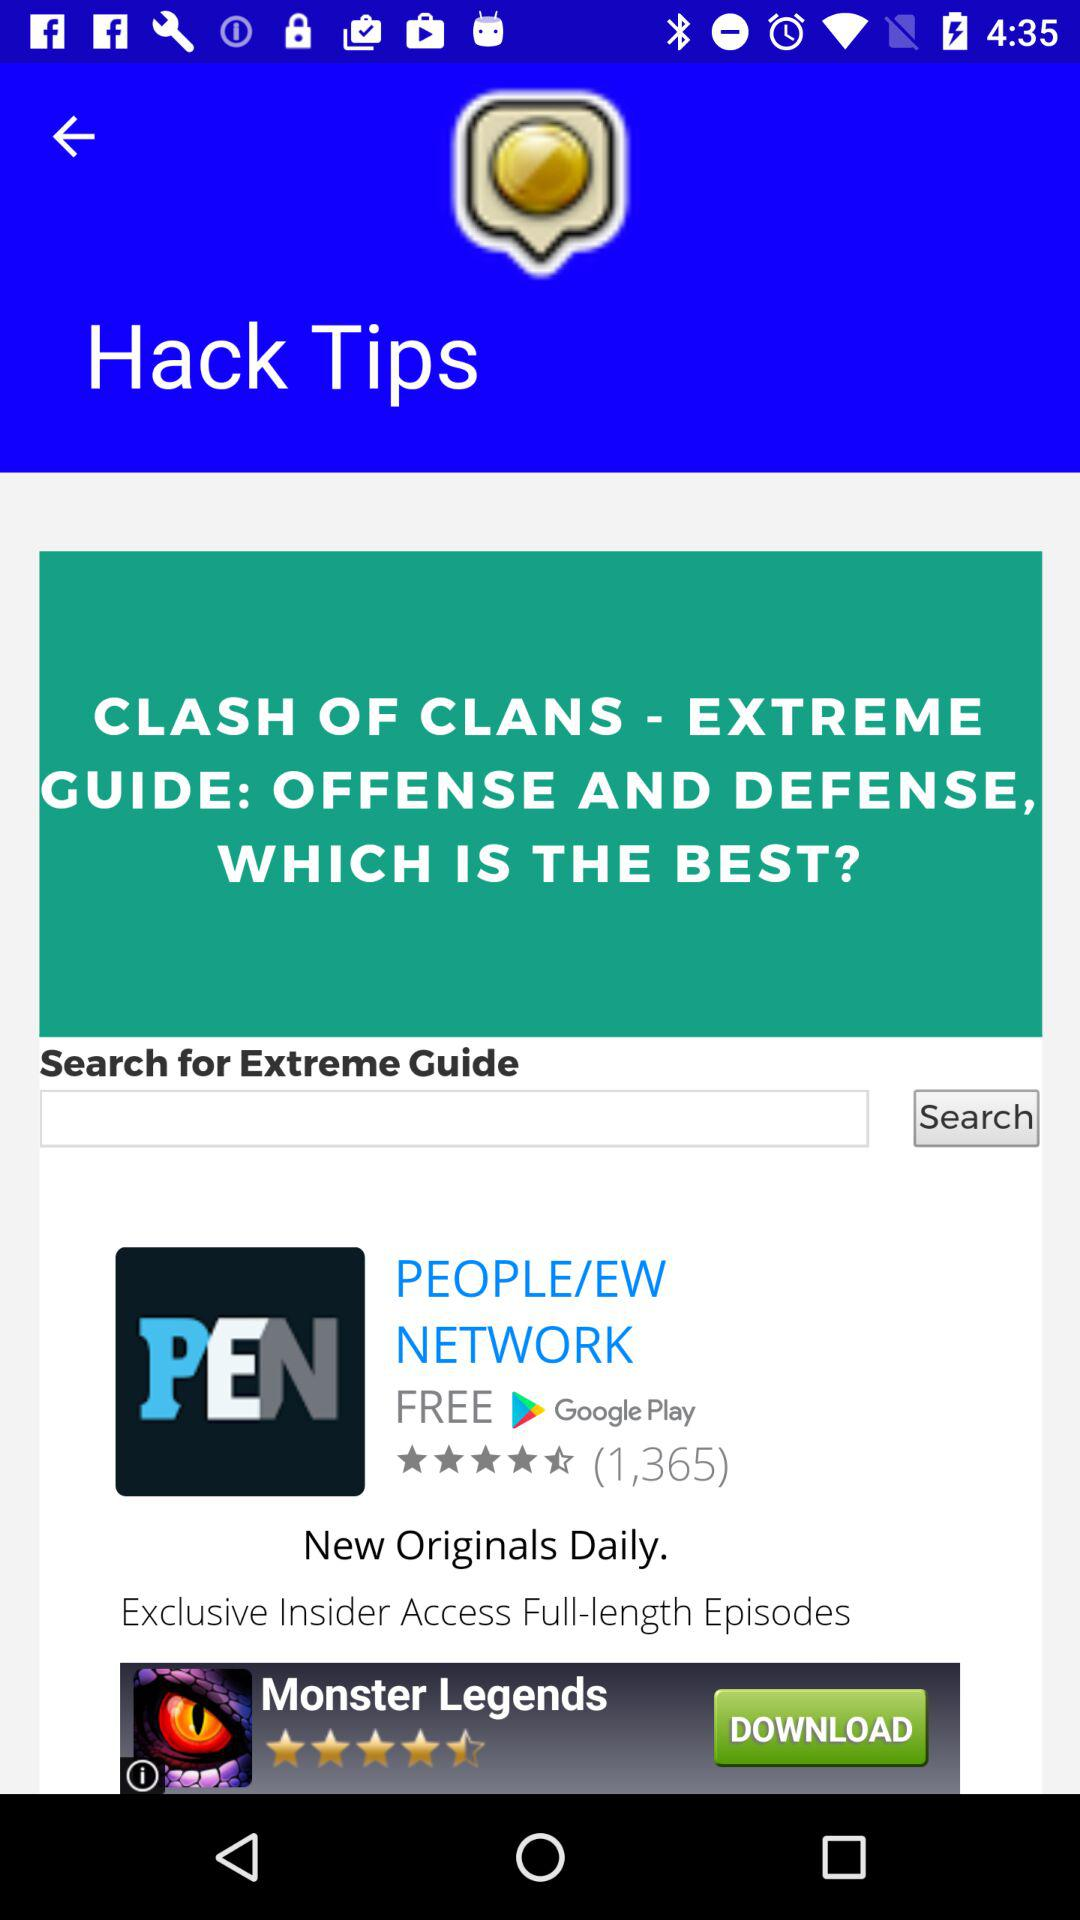What is the rating of "PEN" application? The rating is 4.5 stars. 